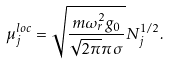<formula> <loc_0><loc_0><loc_500><loc_500>\mu _ { j } ^ { l o c } = \sqrt { \frac { m \omega _ { r } ^ { 2 } g _ { 0 } } { \sqrt { 2 \pi } \pi \sigma } } N _ { j } ^ { 1 / 2 } .</formula> 